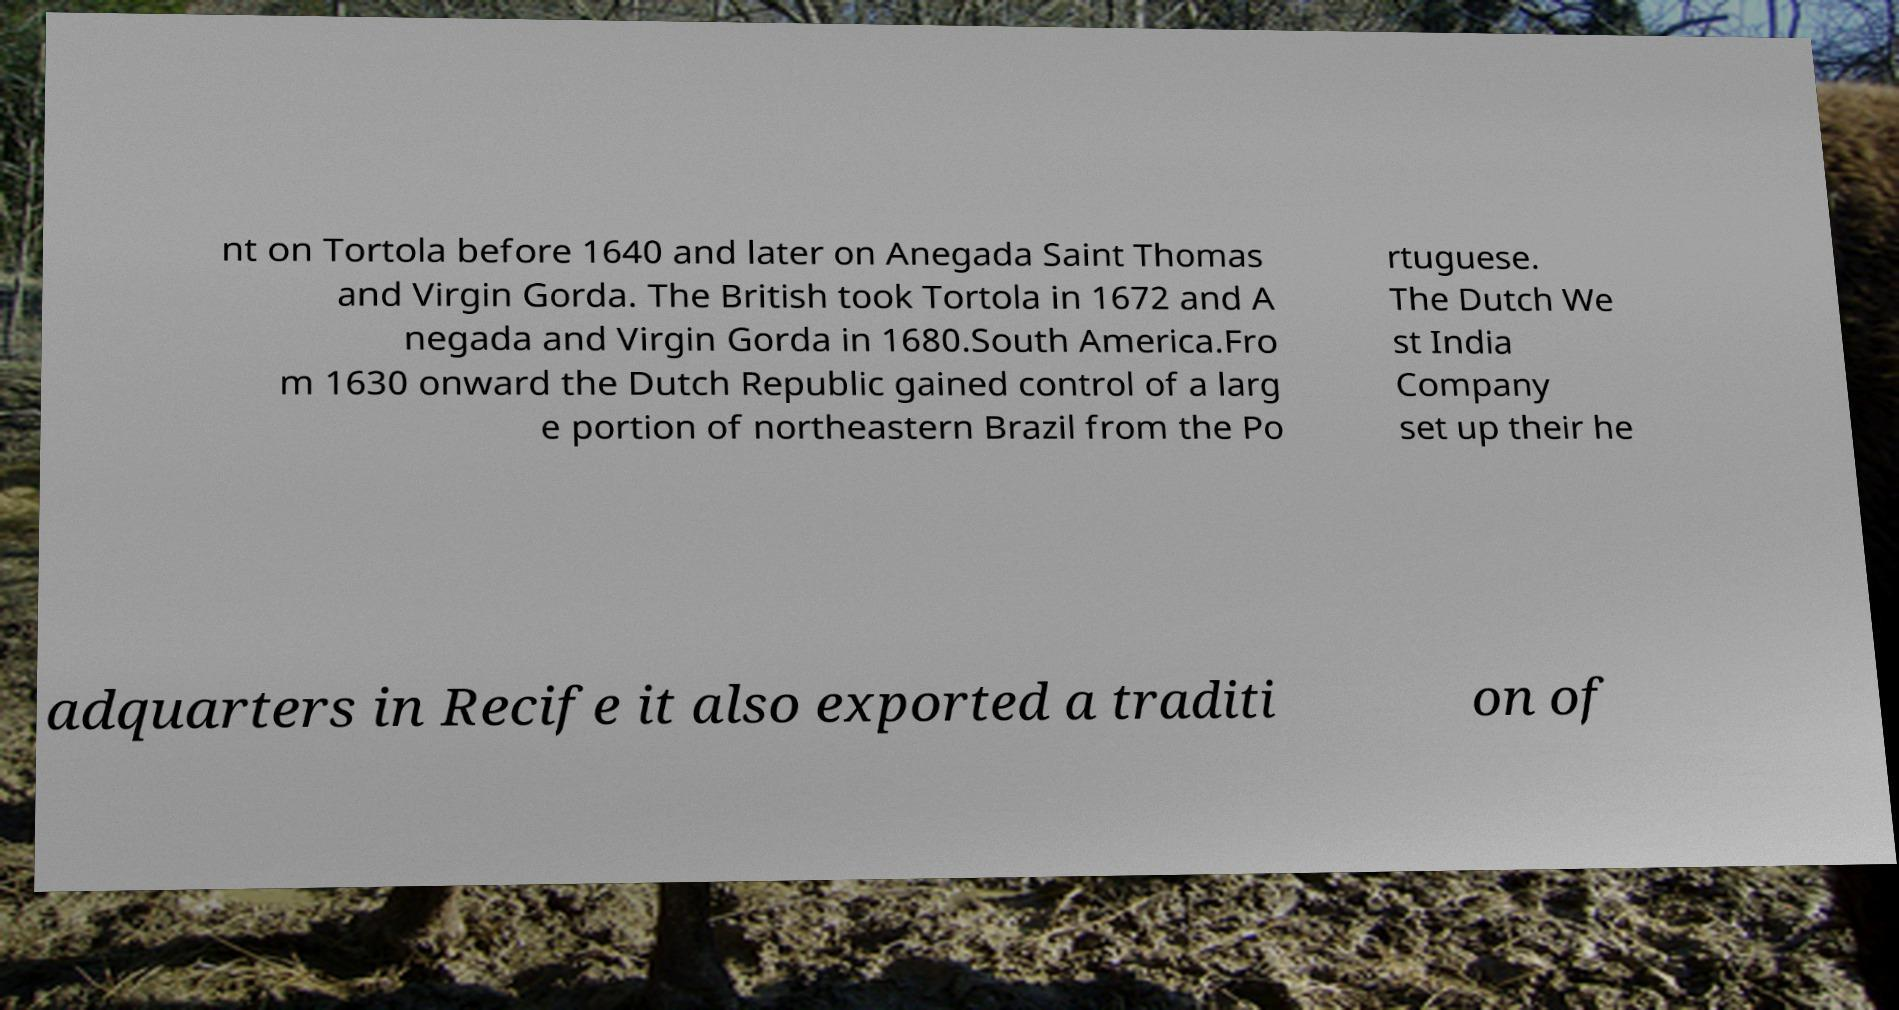Please read and relay the text visible in this image. What does it say? nt on Tortola before 1640 and later on Anegada Saint Thomas and Virgin Gorda. The British took Tortola in 1672 and A negada and Virgin Gorda in 1680.South America.Fro m 1630 onward the Dutch Republic gained control of a larg e portion of northeastern Brazil from the Po rtuguese. The Dutch We st India Company set up their he adquarters in Recife it also exported a traditi on of 